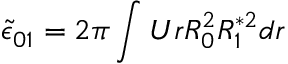<formula> <loc_0><loc_0><loc_500><loc_500>\tilde { \epsilon } _ { 0 1 } = 2 \pi \int U r R _ { 0 } ^ { 2 } R _ { 1 } ^ { * 2 } d r</formula> 